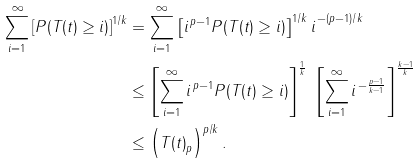Convert formula to latex. <formula><loc_0><loc_0><loc_500><loc_500>\sum _ { i = 1 } ^ { \infty } \left [ P ( T ( t ) \geq i ) \right ] ^ { 1 / k } & = \sum _ { i = 1 } ^ { \infty } \left [ i ^ { \, p - 1 } P ( T ( t ) \geq i ) \right ] ^ { 1 / k } { \strut i } ^ { \, - ( p - 1 ) / k } \\ & \leq \left [ \sum _ { i = 1 } ^ { \infty } i ^ { \, p - 1 } P ( T ( t ) \geq i ) \right ] ^ { \frac { 1 } { k } } \ \left [ \sum _ { i = 1 } ^ { \infty } { \strut } i ^ { \, - \frac { p - 1 } { k - 1 } } \right ] ^ { \frac { k - 1 } { k } } \\ & \leq \left ( { \| T ( t ) \| } _ { p } \right ) ^ { p / k } .</formula> 